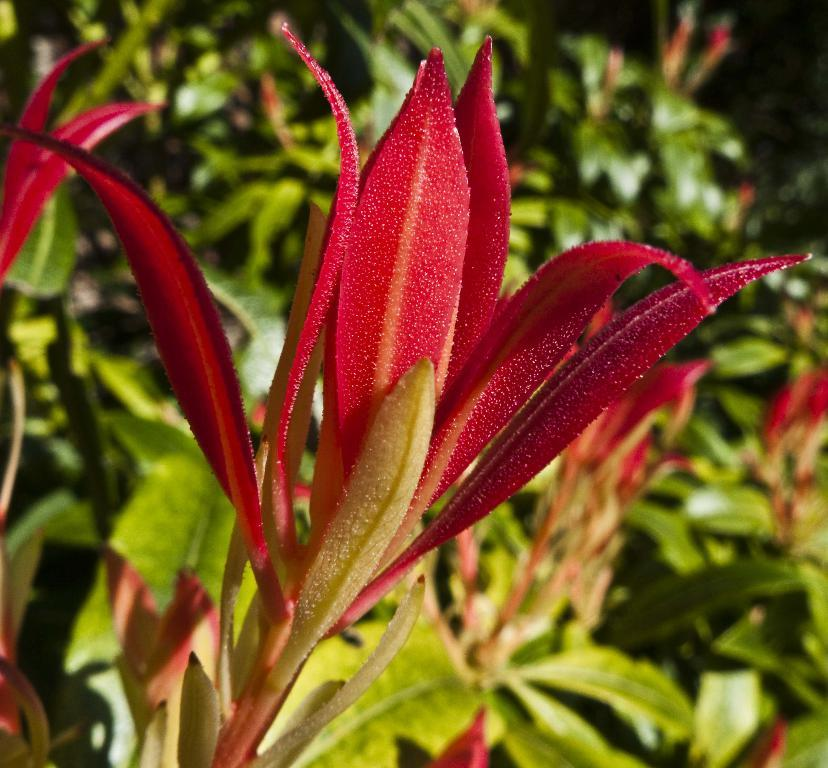What type of flower is present in the image? There is a red color flower in the image. What is the flower a part of? The flower is part of a plant. Where is the plant located in the image? The plant is in the middle of the image. What can be seen in the background of the image? There are plants with green color leaves in the background of the image. Are there any flowers visible on the plants in the background? Yes, some of the plants in the background have flowers. What ideas does the dad have about the list in the image? There is no dad or list present in the image; it features a red color flower and plants. 